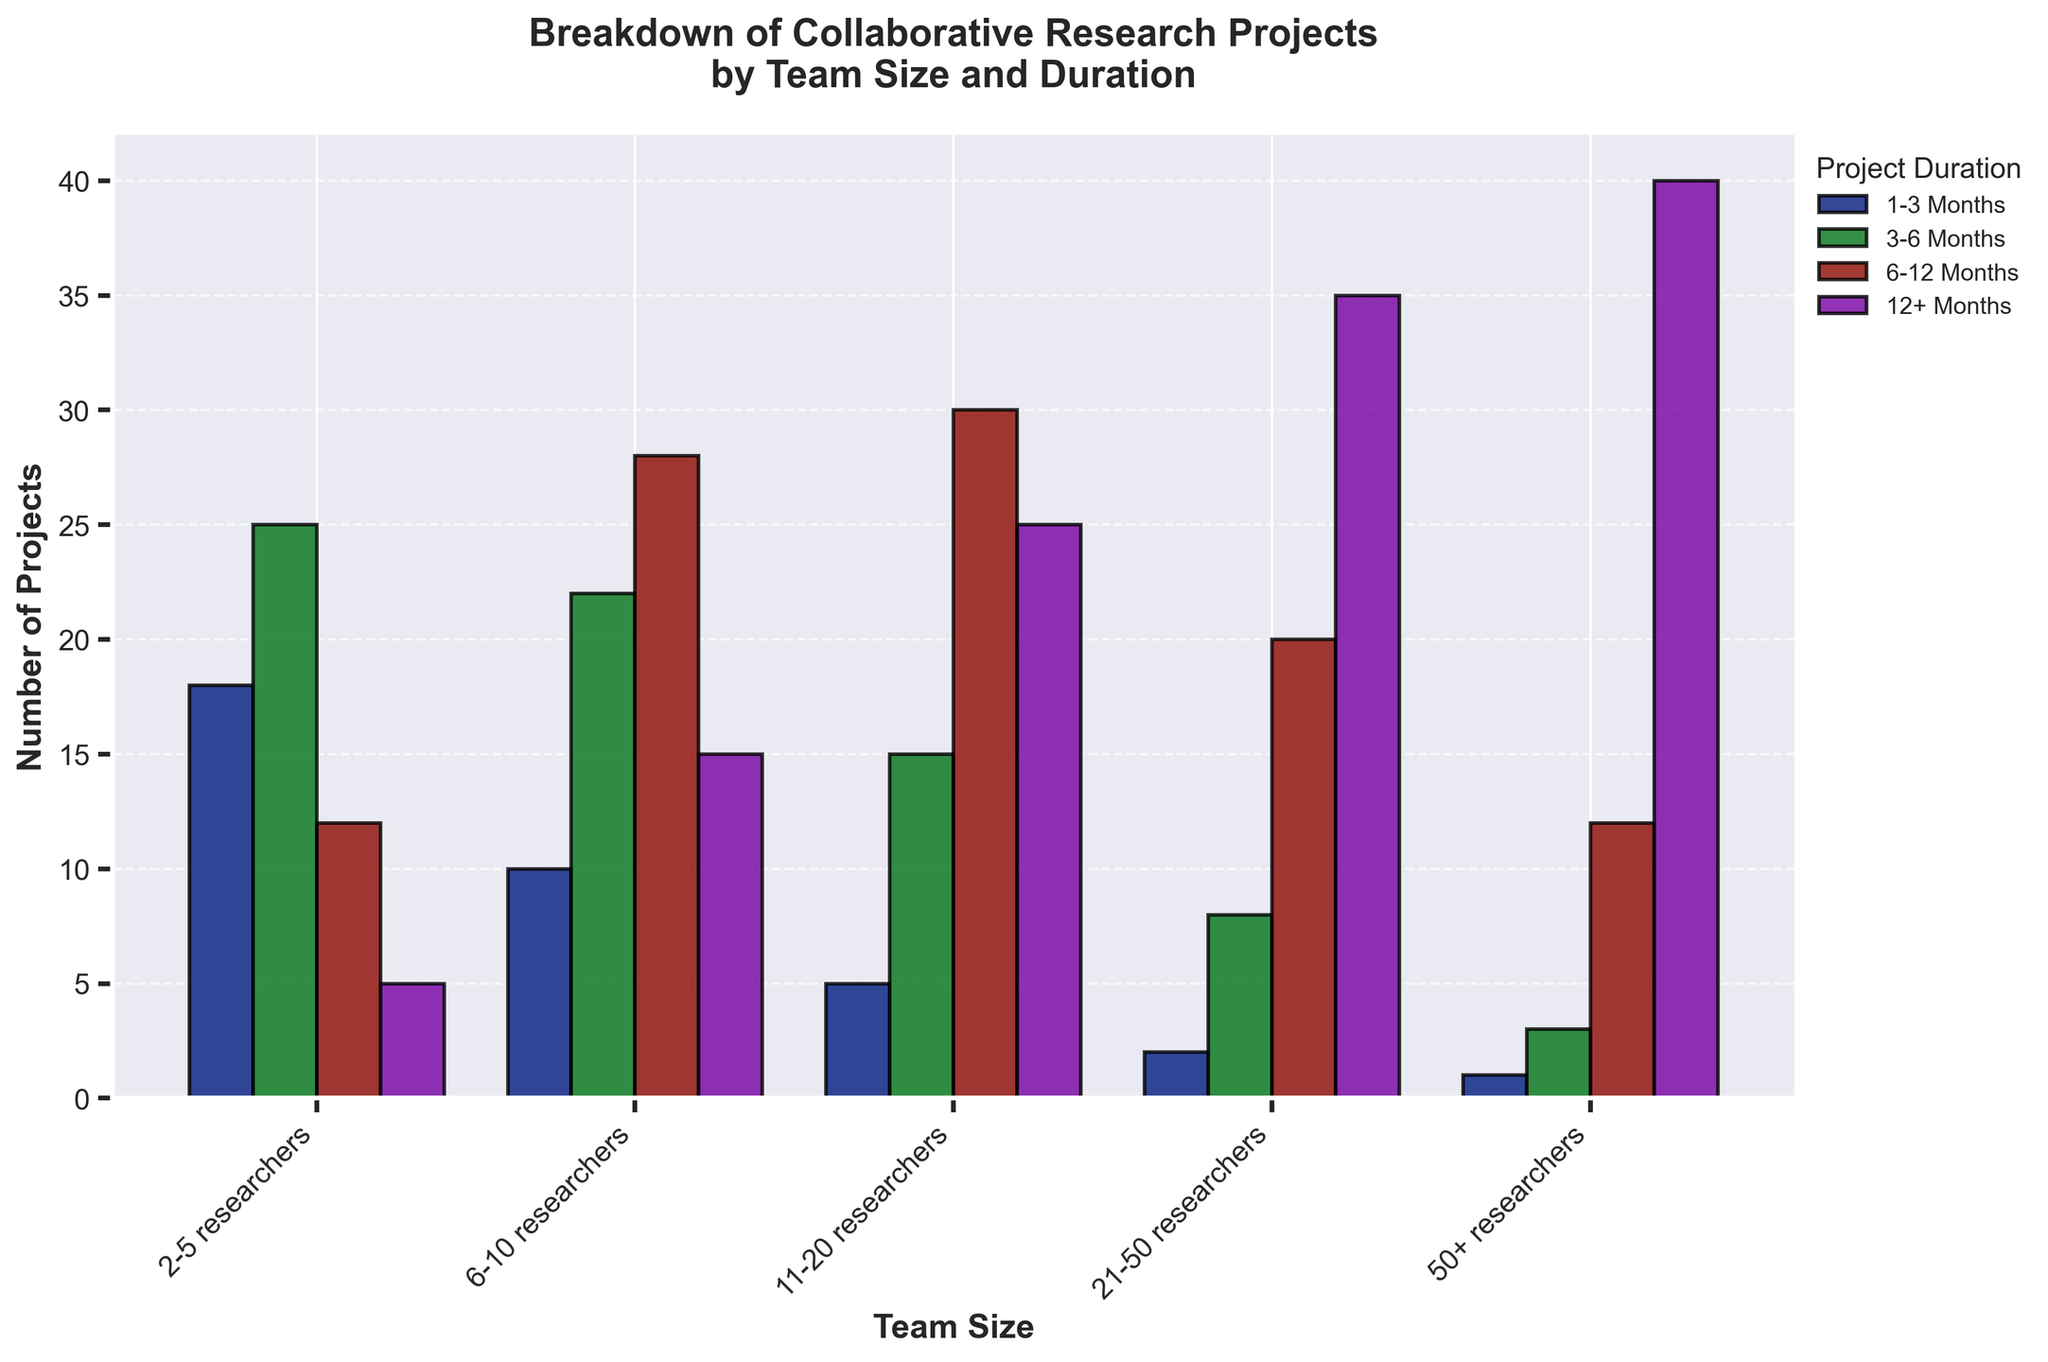Which team size has the highest number of projects lasting 1-3 months? Look at the bar heights corresponding to the 1-3 months duration and compare them across different team sizes. The tallest bar indicates the highest number of projects.
Answer: 2-5 researchers Which team size has the lowest number of projects for a duration of 12+ months? Look at the bars representing projects lasting 12+ months and identify the shortest bar.
Answer: 2-5 researchers How many total projects are there for team sizes of 6-10 and 11-20 researchers lasting 6-12 months? Add the number of projects for 6-10 researchers and 11-20 researchers for the 6-12 months duration. That is, 28 + 30.
Answer: 58 Which duration has the most projects for the team size of 21-50 researchers? Examine the heights of the bars for the 21-50 researchers team size. The tallest bar corresponds to the duration with the most projects.
Answer: 12+ months How many more projects do teams with 50+ researchers have lasting 12+ months than those lasting 1-3 months? Subtract the number of projects lasting 1-3 months from those lasting 12+ months for the 50+ researchers team size. That is, 40 - 1.
Answer: 39 Compare the number of projects lasting 3-6 months between teams with 6-10 researchers and teams with 2-5 researchers. Compare the height of the 3-6 months bar for both team sizes. There are 22 projects for 6-10 researchers and 25 for 2-5 researchers.
Answer: 2-5 researchers have 3 more projects Which team size has the most projects overall? Sum the project counts for all durations for each team size and compare the totals. For example:
- 2-5 researchers: 18+25+12+5 = 60
- 6-10 researchers: 10+22+28+15 = 75
- 11-20 researchers: 5+15+30+25 = 75
- 21-50 researchers: 2+8+20+35 = 65
- 50+ researchers: 1+3+12+40 = 56
The highest total is for team sizes 6-10 and 11-20.
Answer: 6-10 researchers and 11-20 researchers What's the combined total of all projects for all team sizes lasting 1-3 months? Add up the number of projects for the 1-3 months duration across all team sizes. That is, 18 + 10 + 5 + 2 + 1.
Answer: 36 